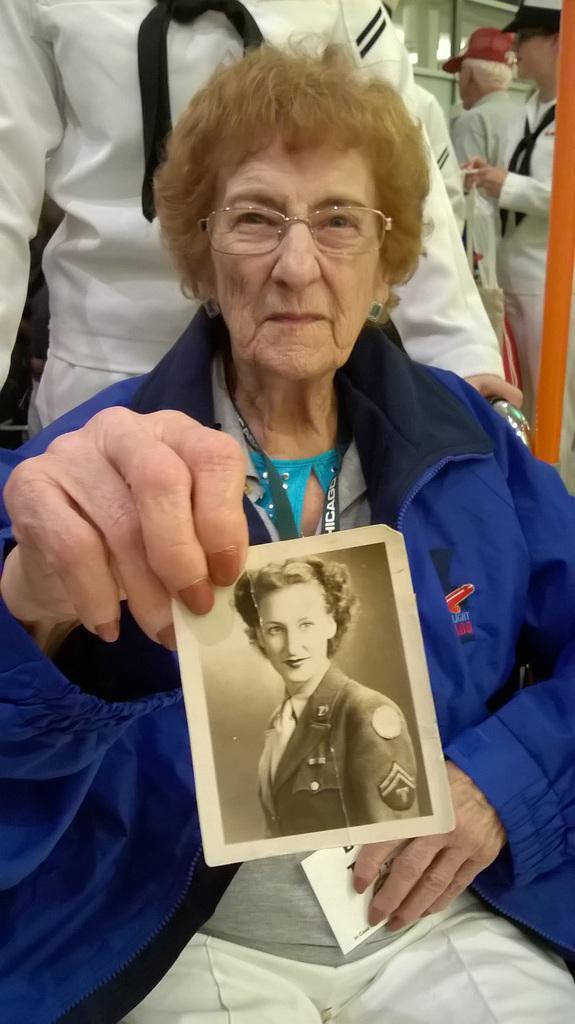Describe this image in one or two sentences. In the image we can see a woman wearing clothes, identity cards, spectacles and earrings, she is holding a photo in her hand and in the photo there is a person. Behind her there are other people standing and wearing clothes. 